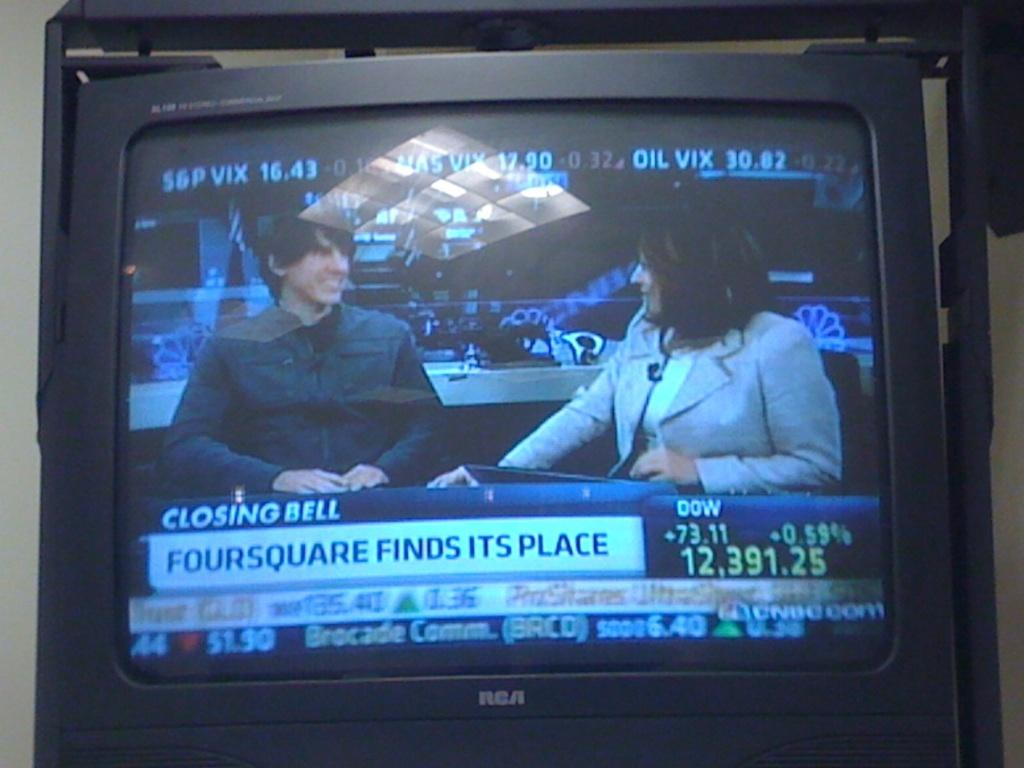<image>
Render a clear and concise summary of the photo. The RCA tv shows two people talking and below them on the screen shows the DOW is up 73.11. 